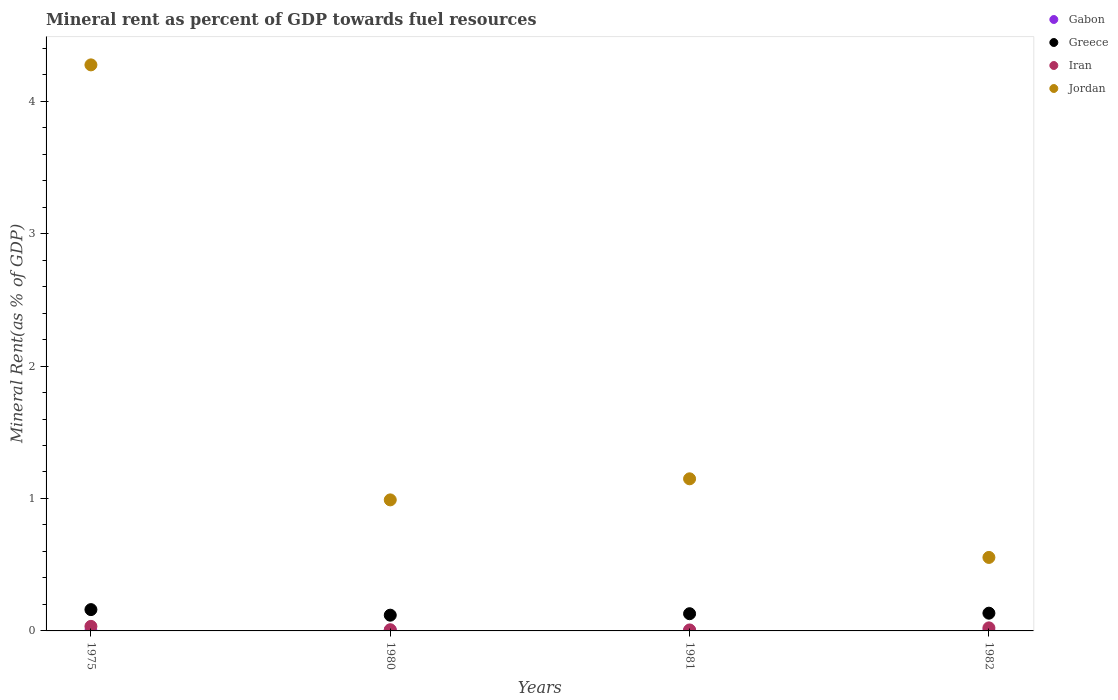What is the mineral rent in Iran in 1982?
Provide a short and direct response. 0.02. Across all years, what is the maximum mineral rent in Gabon?
Your response must be concise. 0. Across all years, what is the minimum mineral rent in Greece?
Your answer should be compact. 0.12. In which year was the mineral rent in Jordan maximum?
Your response must be concise. 1975. In which year was the mineral rent in Jordan minimum?
Your answer should be compact. 1982. What is the total mineral rent in Gabon in the graph?
Offer a very short reply. 0.01. What is the difference between the mineral rent in Gabon in 1975 and that in 1982?
Make the answer very short. -0. What is the difference between the mineral rent in Jordan in 1981 and the mineral rent in Greece in 1982?
Make the answer very short. 1.01. What is the average mineral rent in Jordan per year?
Your answer should be very brief. 1.74. In the year 1982, what is the difference between the mineral rent in Greece and mineral rent in Iran?
Your answer should be compact. 0.11. What is the ratio of the mineral rent in Greece in 1975 to that in 1981?
Ensure brevity in your answer.  1.24. What is the difference between the highest and the second highest mineral rent in Jordan?
Make the answer very short. 3.13. What is the difference between the highest and the lowest mineral rent in Gabon?
Your answer should be compact. 0. Is the sum of the mineral rent in Greece in 1980 and 1981 greater than the maximum mineral rent in Gabon across all years?
Your answer should be very brief. Yes. Is the mineral rent in Gabon strictly greater than the mineral rent in Greece over the years?
Your answer should be compact. No. Is the mineral rent in Greece strictly less than the mineral rent in Iran over the years?
Give a very brief answer. No. How many years are there in the graph?
Provide a succinct answer. 4. What is the difference between two consecutive major ticks on the Y-axis?
Provide a short and direct response. 1. Does the graph contain any zero values?
Your response must be concise. No. How many legend labels are there?
Offer a very short reply. 4. How are the legend labels stacked?
Provide a succinct answer. Vertical. What is the title of the graph?
Give a very brief answer. Mineral rent as percent of GDP towards fuel resources. What is the label or title of the Y-axis?
Your response must be concise. Mineral Rent(as % of GDP). What is the Mineral Rent(as % of GDP) of Gabon in 1975?
Offer a terse response. 0. What is the Mineral Rent(as % of GDP) in Greece in 1975?
Offer a terse response. 0.16. What is the Mineral Rent(as % of GDP) in Iran in 1975?
Your answer should be very brief. 0.03. What is the Mineral Rent(as % of GDP) of Jordan in 1975?
Offer a terse response. 4.27. What is the Mineral Rent(as % of GDP) of Gabon in 1980?
Your answer should be compact. 0. What is the Mineral Rent(as % of GDP) of Greece in 1980?
Make the answer very short. 0.12. What is the Mineral Rent(as % of GDP) of Iran in 1980?
Your answer should be compact. 0.01. What is the Mineral Rent(as % of GDP) in Jordan in 1980?
Your answer should be very brief. 0.99. What is the Mineral Rent(as % of GDP) in Gabon in 1981?
Keep it short and to the point. 0. What is the Mineral Rent(as % of GDP) of Greece in 1981?
Keep it short and to the point. 0.13. What is the Mineral Rent(as % of GDP) of Iran in 1981?
Provide a short and direct response. 0.01. What is the Mineral Rent(as % of GDP) of Jordan in 1981?
Your answer should be compact. 1.15. What is the Mineral Rent(as % of GDP) of Gabon in 1982?
Provide a succinct answer. 0. What is the Mineral Rent(as % of GDP) in Greece in 1982?
Your answer should be very brief. 0.13. What is the Mineral Rent(as % of GDP) of Iran in 1982?
Make the answer very short. 0.02. What is the Mineral Rent(as % of GDP) of Jordan in 1982?
Give a very brief answer. 0.55. Across all years, what is the maximum Mineral Rent(as % of GDP) in Gabon?
Your answer should be compact. 0. Across all years, what is the maximum Mineral Rent(as % of GDP) in Greece?
Provide a succinct answer. 0.16. Across all years, what is the maximum Mineral Rent(as % of GDP) of Iran?
Provide a short and direct response. 0.03. Across all years, what is the maximum Mineral Rent(as % of GDP) of Jordan?
Your response must be concise. 4.27. Across all years, what is the minimum Mineral Rent(as % of GDP) of Gabon?
Your answer should be very brief. 0. Across all years, what is the minimum Mineral Rent(as % of GDP) of Greece?
Your answer should be very brief. 0.12. Across all years, what is the minimum Mineral Rent(as % of GDP) in Iran?
Make the answer very short. 0.01. Across all years, what is the minimum Mineral Rent(as % of GDP) in Jordan?
Your answer should be very brief. 0.55. What is the total Mineral Rent(as % of GDP) of Gabon in the graph?
Your answer should be very brief. 0.01. What is the total Mineral Rent(as % of GDP) in Greece in the graph?
Give a very brief answer. 0.54. What is the total Mineral Rent(as % of GDP) in Iran in the graph?
Provide a short and direct response. 0.07. What is the total Mineral Rent(as % of GDP) in Jordan in the graph?
Make the answer very short. 6.97. What is the difference between the Mineral Rent(as % of GDP) in Gabon in 1975 and that in 1980?
Give a very brief answer. -0. What is the difference between the Mineral Rent(as % of GDP) of Greece in 1975 and that in 1980?
Your answer should be compact. 0.04. What is the difference between the Mineral Rent(as % of GDP) of Iran in 1975 and that in 1980?
Give a very brief answer. 0.03. What is the difference between the Mineral Rent(as % of GDP) in Jordan in 1975 and that in 1980?
Your response must be concise. 3.28. What is the difference between the Mineral Rent(as % of GDP) of Gabon in 1975 and that in 1981?
Ensure brevity in your answer.  -0. What is the difference between the Mineral Rent(as % of GDP) in Greece in 1975 and that in 1981?
Your answer should be compact. 0.03. What is the difference between the Mineral Rent(as % of GDP) of Iran in 1975 and that in 1981?
Provide a succinct answer. 0.03. What is the difference between the Mineral Rent(as % of GDP) of Jordan in 1975 and that in 1981?
Provide a succinct answer. 3.13. What is the difference between the Mineral Rent(as % of GDP) in Gabon in 1975 and that in 1982?
Give a very brief answer. -0. What is the difference between the Mineral Rent(as % of GDP) of Greece in 1975 and that in 1982?
Offer a terse response. 0.03. What is the difference between the Mineral Rent(as % of GDP) in Iran in 1975 and that in 1982?
Make the answer very short. 0.01. What is the difference between the Mineral Rent(as % of GDP) in Jordan in 1975 and that in 1982?
Offer a terse response. 3.72. What is the difference between the Mineral Rent(as % of GDP) of Gabon in 1980 and that in 1981?
Keep it short and to the point. 0. What is the difference between the Mineral Rent(as % of GDP) of Greece in 1980 and that in 1981?
Keep it short and to the point. -0.01. What is the difference between the Mineral Rent(as % of GDP) of Iran in 1980 and that in 1981?
Keep it short and to the point. 0. What is the difference between the Mineral Rent(as % of GDP) in Jordan in 1980 and that in 1981?
Keep it short and to the point. -0.16. What is the difference between the Mineral Rent(as % of GDP) in Gabon in 1980 and that in 1982?
Your answer should be compact. 0. What is the difference between the Mineral Rent(as % of GDP) in Greece in 1980 and that in 1982?
Offer a terse response. -0.02. What is the difference between the Mineral Rent(as % of GDP) in Iran in 1980 and that in 1982?
Your answer should be compact. -0.01. What is the difference between the Mineral Rent(as % of GDP) in Jordan in 1980 and that in 1982?
Your answer should be compact. 0.43. What is the difference between the Mineral Rent(as % of GDP) in Greece in 1981 and that in 1982?
Provide a succinct answer. -0. What is the difference between the Mineral Rent(as % of GDP) in Iran in 1981 and that in 1982?
Provide a short and direct response. -0.02. What is the difference between the Mineral Rent(as % of GDP) in Jordan in 1981 and that in 1982?
Keep it short and to the point. 0.59. What is the difference between the Mineral Rent(as % of GDP) in Gabon in 1975 and the Mineral Rent(as % of GDP) in Greece in 1980?
Your response must be concise. -0.12. What is the difference between the Mineral Rent(as % of GDP) in Gabon in 1975 and the Mineral Rent(as % of GDP) in Iran in 1980?
Keep it short and to the point. -0.01. What is the difference between the Mineral Rent(as % of GDP) in Gabon in 1975 and the Mineral Rent(as % of GDP) in Jordan in 1980?
Make the answer very short. -0.99. What is the difference between the Mineral Rent(as % of GDP) of Greece in 1975 and the Mineral Rent(as % of GDP) of Iran in 1980?
Provide a succinct answer. 0.15. What is the difference between the Mineral Rent(as % of GDP) of Greece in 1975 and the Mineral Rent(as % of GDP) of Jordan in 1980?
Ensure brevity in your answer.  -0.83. What is the difference between the Mineral Rent(as % of GDP) in Iran in 1975 and the Mineral Rent(as % of GDP) in Jordan in 1980?
Your answer should be very brief. -0.95. What is the difference between the Mineral Rent(as % of GDP) of Gabon in 1975 and the Mineral Rent(as % of GDP) of Greece in 1981?
Provide a short and direct response. -0.13. What is the difference between the Mineral Rent(as % of GDP) in Gabon in 1975 and the Mineral Rent(as % of GDP) in Iran in 1981?
Offer a terse response. -0.01. What is the difference between the Mineral Rent(as % of GDP) of Gabon in 1975 and the Mineral Rent(as % of GDP) of Jordan in 1981?
Provide a succinct answer. -1.15. What is the difference between the Mineral Rent(as % of GDP) in Greece in 1975 and the Mineral Rent(as % of GDP) in Iran in 1981?
Provide a succinct answer. 0.15. What is the difference between the Mineral Rent(as % of GDP) in Greece in 1975 and the Mineral Rent(as % of GDP) in Jordan in 1981?
Offer a terse response. -0.99. What is the difference between the Mineral Rent(as % of GDP) in Iran in 1975 and the Mineral Rent(as % of GDP) in Jordan in 1981?
Make the answer very short. -1.11. What is the difference between the Mineral Rent(as % of GDP) of Gabon in 1975 and the Mineral Rent(as % of GDP) of Greece in 1982?
Ensure brevity in your answer.  -0.13. What is the difference between the Mineral Rent(as % of GDP) of Gabon in 1975 and the Mineral Rent(as % of GDP) of Iran in 1982?
Make the answer very short. -0.02. What is the difference between the Mineral Rent(as % of GDP) in Gabon in 1975 and the Mineral Rent(as % of GDP) in Jordan in 1982?
Offer a terse response. -0.55. What is the difference between the Mineral Rent(as % of GDP) of Greece in 1975 and the Mineral Rent(as % of GDP) of Iran in 1982?
Your answer should be compact. 0.14. What is the difference between the Mineral Rent(as % of GDP) in Greece in 1975 and the Mineral Rent(as % of GDP) in Jordan in 1982?
Provide a short and direct response. -0.39. What is the difference between the Mineral Rent(as % of GDP) in Iran in 1975 and the Mineral Rent(as % of GDP) in Jordan in 1982?
Make the answer very short. -0.52. What is the difference between the Mineral Rent(as % of GDP) in Gabon in 1980 and the Mineral Rent(as % of GDP) in Greece in 1981?
Your answer should be very brief. -0.13. What is the difference between the Mineral Rent(as % of GDP) in Gabon in 1980 and the Mineral Rent(as % of GDP) in Iran in 1981?
Keep it short and to the point. -0. What is the difference between the Mineral Rent(as % of GDP) in Gabon in 1980 and the Mineral Rent(as % of GDP) in Jordan in 1981?
Your response must be concise. -1.14. What is the difference between the Mineral Rent(as % of GDP) of Greece in 1980 and the Mineral Rent(as % of GDP) of Iran in 1981?
Your response must be concise. 0.11. What is the difference between the Mineral Rent(as % of GDP) in Greece in 1980 and the Mineral Rent(as % of GDP) in Jordan in 1981?
Offer a very short reply. -1.03. What is the difference between the Mineral Rent(as % of GDP) in Iran in 1980 and the Mineral Rent(as % of GDP) in Jordan in 1981?
Your answer should be very brief. -1.14. What is the difference between the Mineral Rent(as % of GDP) in Gabon in 1980 and the Mineral Rent(as % of GDP) in Greece in 1982?
Your response must be concise. -0.13. What is the difference between the Mineral Rent(as % of GDP) in Gabon in 1980 and the Mineral Rent(as % of GDP) in Iran in 1982?
Provide a succinct answer. -0.02. What is the difference between the Mineral Rent(as % of GDP) in Gabon in 1980 and the Mineral Rent(as % of GDP) in Jordan in 1982?
Offer a very short reply. -0.55. What is the difference between the Mineral Rent(as % of GDP) of Greece in 1980 and the Mineral Rent(as % of GDP) of Iran in 1982?
Keep it short and to the point. 0.1. What is the difference between the Mineral Rent(as % of GDP) in Greece in 1980 and the Mineral Rent(as % of GDP) in Jordan in 1982?
Make the answer very short. -0.44. What is the difference between the Mineral Rent(as % of GDP) in Iran in 1980 and the Mineral Rent(as % of GDP) in Jordan in 1982?
Provide a short and direct response. -0.55. What is the difference between the Mineral Rent(as % of GDP) of Gabon in 1981 and the Mineral Rent(as % of GDP) of Greece in 1982?
Offer a terse response. -0.13. What is the difference between the Mineral Rent(as % of GDP) of Gabon in 1981 and the Mineral Rent(as % of GDP) of Iran in 1982?
Your response must be concise. -0.02. What is the difference between the Mineral Rent(as % of GDP) of Gabon in 1981 and the Mineral Rent(as % of GDP) of Jordan in 1982?
Offer a terse response. -0.55. What is the difference between the Mineral Rent(as % of GDP) of Greece in 1981 and the Mineral Rent(as % of GDP) of Iran in 1982?
Provide a short and direct response. 0.11. What is the difference between the Mineral Rent(as % of GDP) in Greece in 1981 and the Mineral Rent(as % of GDP) in Jordan in 1982?
Your answer should be very brief. -0.42. What is the difference between the Mineral Rent(as % of GDP) of Iran in 1981 and the Mineral Rent(as % of GDP) of Jordan in 1982?
Offer a very short reply. -0.55. What is the average Mineral Rent(as % of GDP) of Gabon per year?
Your response must be concise. 0. What is the average Mineral Rent(as % of GDP) in Greece per year?
Your answer should be compact. 0.14. What is the average Mineral Rent(as % of GDP) in Iran per year?
Provide a succinct answer. 0.02. What is the average Mineral Rent(as % of GDP) of Jordan per year?
Give a very brief answer. 1.74. In the year 1975, what is the difference between the Mineral Rent(as % of GDP) in Gabon and Mineral Rent(as % of GDP) in Greece?
Keep it short and to the point. -0.16. In the year 1975, what is the difference between the Mineral Rent(as % of GDP) in Gabon and Mineral Rent(as % of GDP) in Iran?
Give a very brief answer. -0.03. In the year 1975, what is the difference between the Mineral Rent(as % of GDP) of Gabon and Mineral Rent(as % of GDP) of Jordan?
Keep it short and to the point. -4.27. In the year 1975, what is the difference between the Mineral Rent(as % of GDP) in Greece and Mineral Rent(as % of GDP) in Iran?
Keep it short and to the point. 0.13. In the year 1975, what is the difference between the Mineral Rent(as % of GDP) in Greece and Mineral Rent(as % of GDP) in Jordan?
Provide a short and direct response. -4.11. In the year 1975, what is the difference between the Mineral Rent(as % of GDP) of Iran and Mineral Rent(as % of GDP) of Jordan?
Your answer should be compact. -4.24. In the year 1980, what is the difference between the Mineral Rent(as % of GDP) in Gabon and Mineral Rent(as % of GDP) in Greece?
Make the answer very short. -0.11. In the year 1980, what is the difference between the Mineral Rent(as % of GDP) of Gabon and Mineral Rent(as % of GDP) of Iran?
Your response must be concise. -0. In the year 1980, what is the difference between the Mineral Rent(as % of GDP) in Gabon and Mineral Rent(as % of GDP) in Jordan?
Offer a very short reply. -0.98. In the year 1980, what is the difference between the Mineral Rent(as % of GDP) of Greece and Mineral Rent(as % of GDP) of Iran?
Give a very brief answer. 0.11. In the year 1980, what is the difference between the Mineral Rent(as % of GDP) of Greece and Mineral Rent(as % of GDP) of Jordan?
Provide a short and direct response. -0.87. In the year 1980, what is the difference between the Mineral Rent(as % of GDP) in Iran and Mineral Rent(as % of GDP) in Jordan?
Offer a very short reply. -0.98. In the year 1981, what is the difference between the Mineral Rent(as % of GDP) in Gabon and Mineral Rent(as % of GDP) in Greece?
Your answer should be very brief. -0.13. In the year 1981, what is the difference between the Mineral Rent(as % of GDP) in Gabon and Mineral Rent(as % of GDP) in Iran?
Ensure brevity in your answer.  -0. In the year 1981, what is the difference between the Mineral Rent(as % of GDP) of Gabon and Mineral Rent(as % of GDP) of Jordan?
Ensure brevity in your answer.  -1.15. In the year 1981, what is the difference between the Mineral Rent(as % of GDP) of Greece and Mineral Rent(as % of GDP) of Iran?
Give a very brief answer. 0.12. In the year 1981, what is the difference between the Mineral Rent(as % of GDP) in Greece and Mineral Rent(as % of GDP) in Jordan?
Ensure brevity in your answer.  -1.02. In the year 1981, what is the difference between the Mineral Rent(as % of GDP) in Iran and Mineral Rent(as % of GDP) in Jordan?
Your answer should be compact. -1.14. In the year 1982, what is the difference between the Mineral Rent(as % of GDP) of Gabon and Mineral Rent(as % of GDP) of Greece?
Your response must be concise. -0.13. In the year 1982, what is the difference between the Mineral Rent(as % of GDP) in Gabon and Mineral Rent(as % of GDP) in Iran?
Provide a succinct answer. -0.02. In the year 1982, what is the difference between the Mineral Rent(as % of GDP) in Gabon and Mineral Rent(as % of GDP) in Jordan?
Give a very brief answer. -0.55. In the year 1982, what is the difference between the Mineral Rent(as % of GDP) in Greece and Mineral Rent(as % of GDP) in Iran?
Make the answer very short. 0.11. In the year 1982, what is the difference between the Mineral Rent(as % of GDP) in Greece and Mineral Rent(as % of GDP) in Jordan?
Offer a very short reply. -0.42. In the year 1982, what is the difference between the Mineral Rent(as % of GDP) of Iran and Mineral Rent(as % of GDP) of Jordan?
Provide a succinct answer. -0.53. What is the ratio of the Mineral Rent(as % of GDP) in Gabon in 1975 to that in 1980?
Offer a very short reply. 0.08. What is the ratio of the Mineral Rent(as % of GDP) in Greece in 1975 to that in 1980?
Give a very brief answer. 1.35. What is the ratio of the Mineral Rent(as % of GDP) in Iran in 1975 to that in 1980?
Make the answer very short. 3.79. What is the ratio of the Mineral Rent(as % of GDP) of Jordan in 1975 to that in 1980?
Offer a very short reply. 4.32. What is the ratio of the Mineral Rent(as % of GDP) in Gabon in 1975 to that in 1981?
Offer a very short reply. 0.12. What is the ratio of the Mineral Rent(as % of GDP) of Greece in 1975 to that in 1981?
Provide a short and direct response. 1.24. What is the ratio of the Mineral Rent(as % of GDP) in Iran in 1975 to that in 1981?
Make the answer very short. 4.65. What is the ratio of the Mineral Rent(as % of GDP) of Jordan in 1975 to that in 1981?
Make the answer very short. 3.72. What is the ratio of the Mineral Rent(as % of GDP) of Gabon in 1975 to that in 1982?
Keep it short and to the point. 0.17. What is the ratio of the Mineral Rent(as % of GDP) in Greece in 1975 to that in 1982?
Your answer should be compact. 1.2. What is the ratio of the Mineral Rent(as % of GDP) in Iran in 1975 to that in 1982?
Provide a short and direct response. 1.49. What is the ratio of the Mineral Rent(as % of GDP) in Jordan in 1975 to that in 1982?
Offer a very short reply. 7.7. What is the ratio of the Mineral Rent(as % of GDP) in Gabon in 1980 to that in 1981?
Provide a short and direct response. 1.54. What is the ratio of the Mineral Rent(as % of GDP) in Greece in 1980 to that in 1981?
Provide a short and direct response. 0.91. What is the ratio of the Mineral Rent(as % of GDP) in Iran in 1980 to that in 1981?
Your answer should be compact. 1.23. What is the ratio of the Mineral Rent(as % of GDP) in Jordan in 1980 to that in 1981?
Offer a terse response. 0.86. What is the ratio of the Mineral Rent(as % of GDP) in Gabon in 1980 to that in 1982?
Your answer should be very brief. 2.26. What is the ratio of the Mineral Rent(as % of GDP) in Greece in 1980 to that in 1982?
Offer a very short reply. 0.89. What is the ratio of the Mineral Rent(as % of GDP) of Iran in 1980 to that in 1982?
Your answer should be compact. 0.39. What is the ratio of the Mineral Rent(as % of GDP) in Jordan in 1980 to that in 1982?
Ensure brevity in your answer.  1.78. What is the ratio of the Mineral Rent(as % of GDP) in Gabon in 1981 to that in 1982?
Offer a terse response. 1.47. What is the ratio of the Mineral Rent(as % of GDP) in Greece in 1981 to that in 1982?
Provide a succinct answer. 0.97. What is the ratio of the Mineral Rent(as % of GDP) of Iran in 1981 to that in 1982?
Provide a succinct answer. 0.32. What is the ratio of the Mineral Rent(as % of GDP) in Jordan in 1981 to that in 1982?
Make the answer very short. 2.07. What is the difference between the highest and the second highest Mineral Rent(as % of GDP) in Gabon?
Keep it short and to the point. 0. What is the difference between the highest and the second highest Mineral Rent(as % of GDP) of Greece?
Give a very brief answer. 0.03. What is the difference between the highest and the second highest Mineral Rent(as % of GDP) of Iran?
Your answer should be compact. 0.01. What is the difference between the highest and the second highest Mineral Rent(as % of GDP) of Jordan?
Your response must be concise. 3.13. What is the difference between the highest and the lowest Mineral Rent(as % of GDP) in Gabon?
Your response must be concise. 0. What is the difference between the highest and the lowest Mineral Rent(as % of GDP) of Greece?
Offer a very short reply. 0.04. What is the difference between the highest and the lowest Mineral Rent(as % of GDP) of Iran?
Offer a terse response. 0.03. What is the difference between the highest and the lowest Mineral Rent(as % of GDP) of Jordan?
Provide a succinct answer. 3.72. 